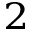<formula> <loc_0><loc_0><loc_500><loc_500>^ { 2 }</formula> 